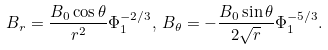<formula> <loc_0><loc_0><loc_500><loc_500>B _ { r } = \frac { B _ { 0 } \cos \theta } { r ^ { 2 } } \Phi _ { 1 } ^ { - 2 / 3 } , \, B _ { \theta } = - \frac { B _ { 0 } \sin \theta } { 2 \sqrt { r } } \Phi _ { 1 } ^ { - 5 / 3 } .</formula> 